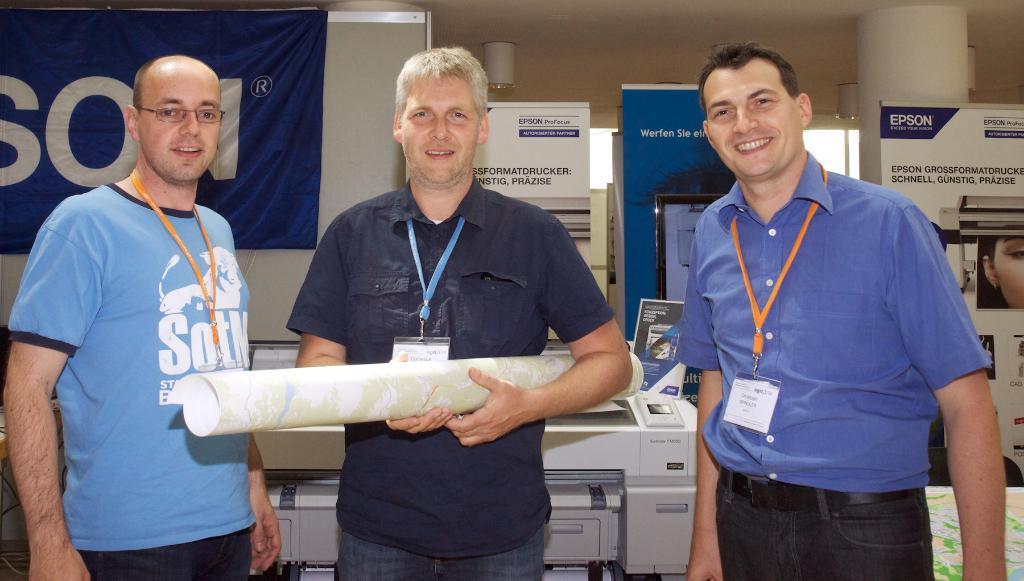Could you give a brief overview of what you see in this image? In this picture, we see three men are standing. Three of them are smiling. The man in the middle of the picture is holding a chart in his hands. Behind them, we see a white table and boards in white and blue color with some text written on each board. Behind that, we see a pillar. On the left side, we see a projector screen and a sheet or a banner in blue color with some text written on it. 